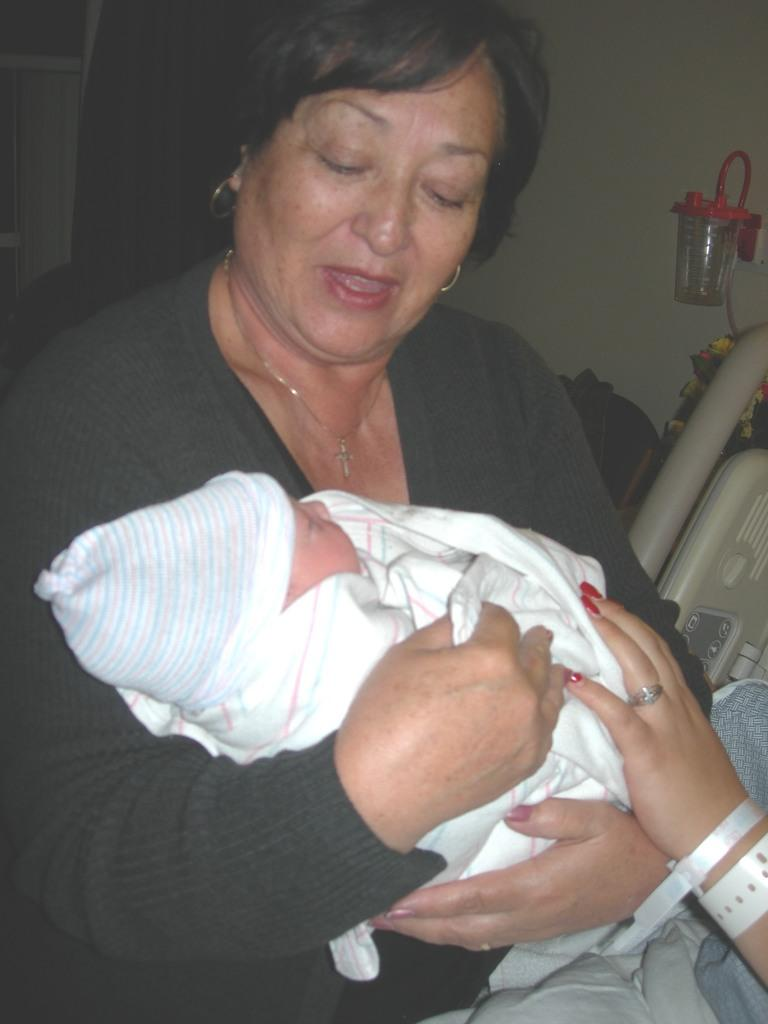What is the main subject of the image? The main subject of the image is a person holding a baby. Can you describe the person beside the person holding the baby? There is another person beside the person holding the baby. What can be seen in the background of the image? There are a few objects and a wall in the background of the image. What type of honey is being used to feed the rabbit in the image? There is no honey or rabbit present in the image. What view can be seen from the window in the image? There is no window visible in the image. 